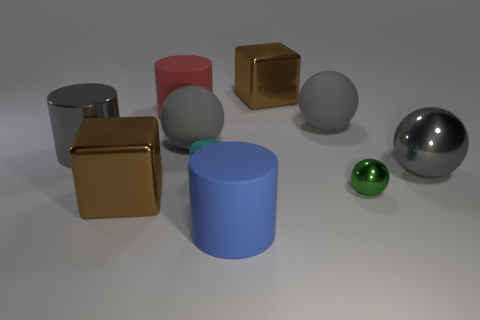How big is the brown object behind the big shiny ball?
Make the answer very short. Large. What number of large metallic blocks have the same color as the big metallic cylinder?
Your answer should be very brief. 0. How many cylinders are cyan things or big metal things?
Provide a short and direct response. 2. What shape is the big shiny thing that is on the right side of the tiny cylinder and on the left side of the green metal object?
Offer a terse response. Cube. Is there a purple rubber block of the same size as the cyan metal object?
Make the answer very short. No. How many things are large matte things that are behind the large blue object or large brown shiny things?
Your answer should be very brief. 5. Is the tiny green ball made of the same material as the big block in front of the big red rubber cylinder?
Your answer should be very brief. Yes. How many other objects are there of the same shape as the red rubber object?
Ensure brevity in your answer.  3. How many objects are metal cubes to the left of the blue rubber cylinder or big brown metal things behind the big red matte thing?
Make the answer very short. 2. How many other things are the same color as the large metallic cylinder?
Your answer should be compact. 3. 